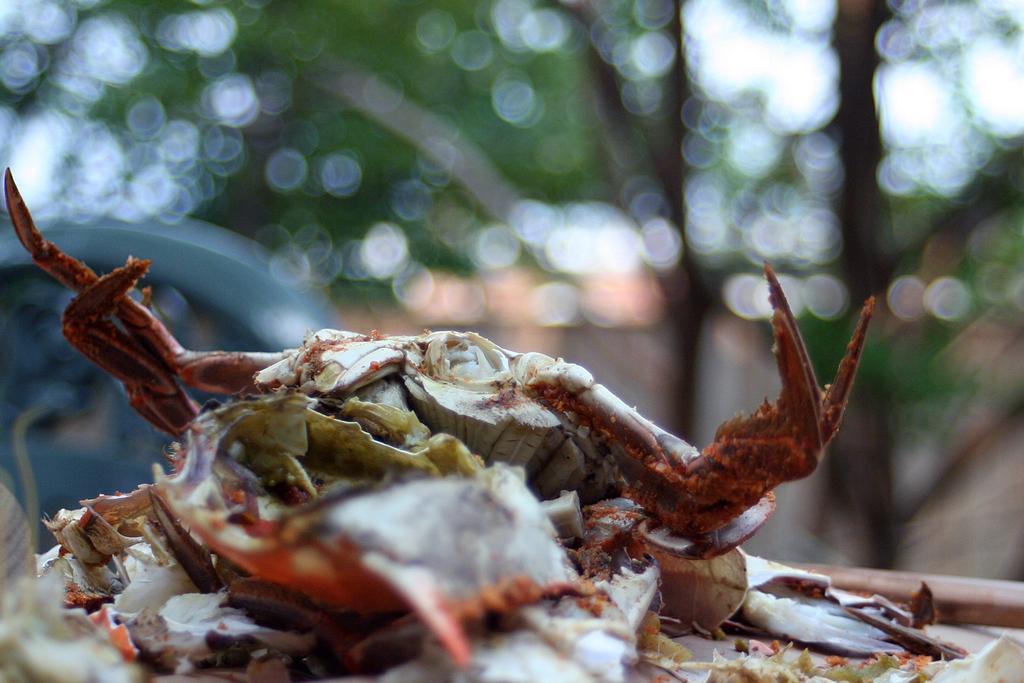Describe this image in one or two sentences. In the image in the center we can see one crab. In the background we can see trees and one vehicle. 